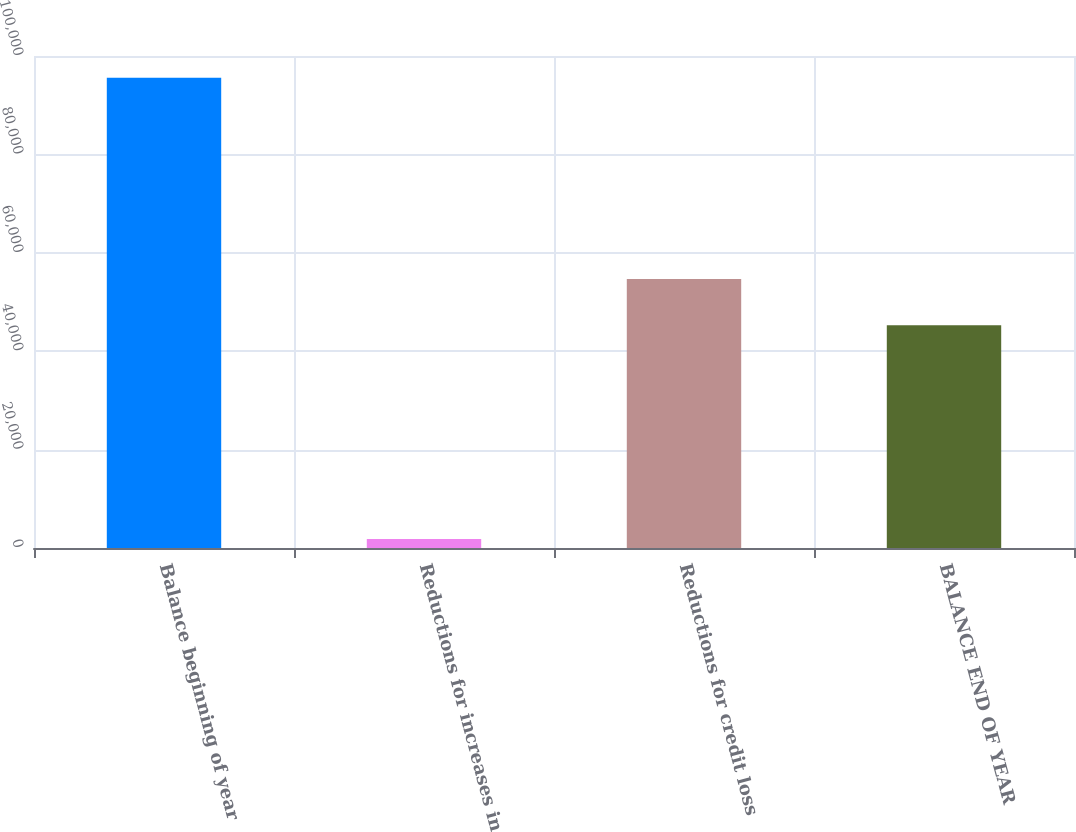Convert chart. <chart><loc_0><loc_0><loc_500><loc_500><bar_chart><fcel>Balance beginning of year<fcel>Reductions for increases in<fcel>Reductions for credit loss<fcel>BALANCE END OF YEAR<nl><fcel>95589<fcel>1851<fcel>54651.8<fcel>45278<nl></chart> 